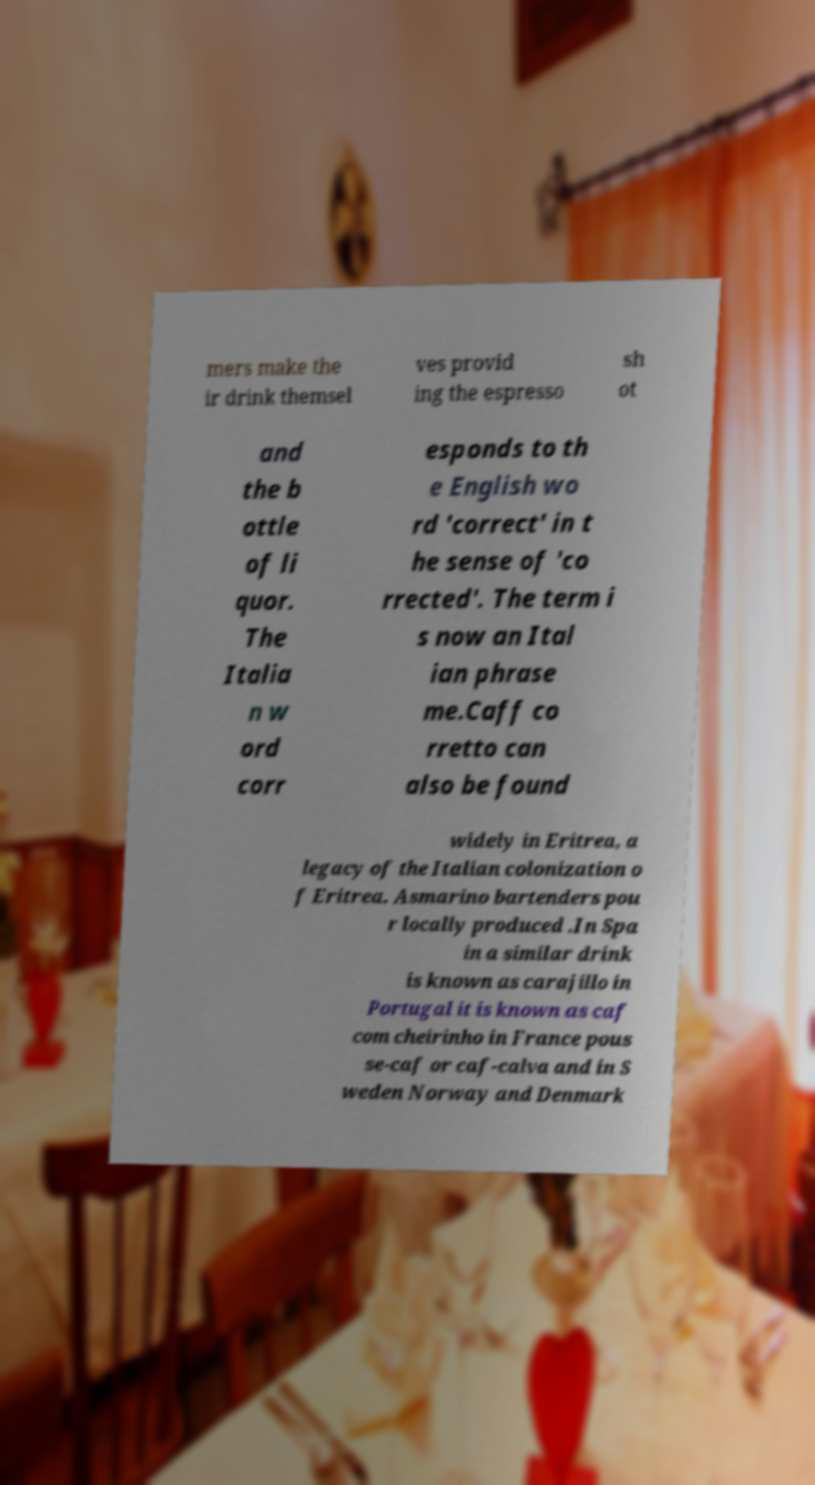Please read and relay the text visible in this image. What does it say? mers make the ir drink themsel ves provid ing the espresso sh ot and the b ottle of li quor. The Italia n w ord corr esponds to th e English wo rd 'correct' in t he sense of 'co rrected'. The term i s now an Ital ian phrase me.Caff co rretto can also be found widely in Eritrea, a legacy of the Italian colonization o f Eritrea. Asmarino bartenders pou r locally produced .In Spa in a similar drink is known as carajillo in Portugal it is known as caf com cheirinho in France pous se-caf or caf-calva and in S weden Norway and Denmark 